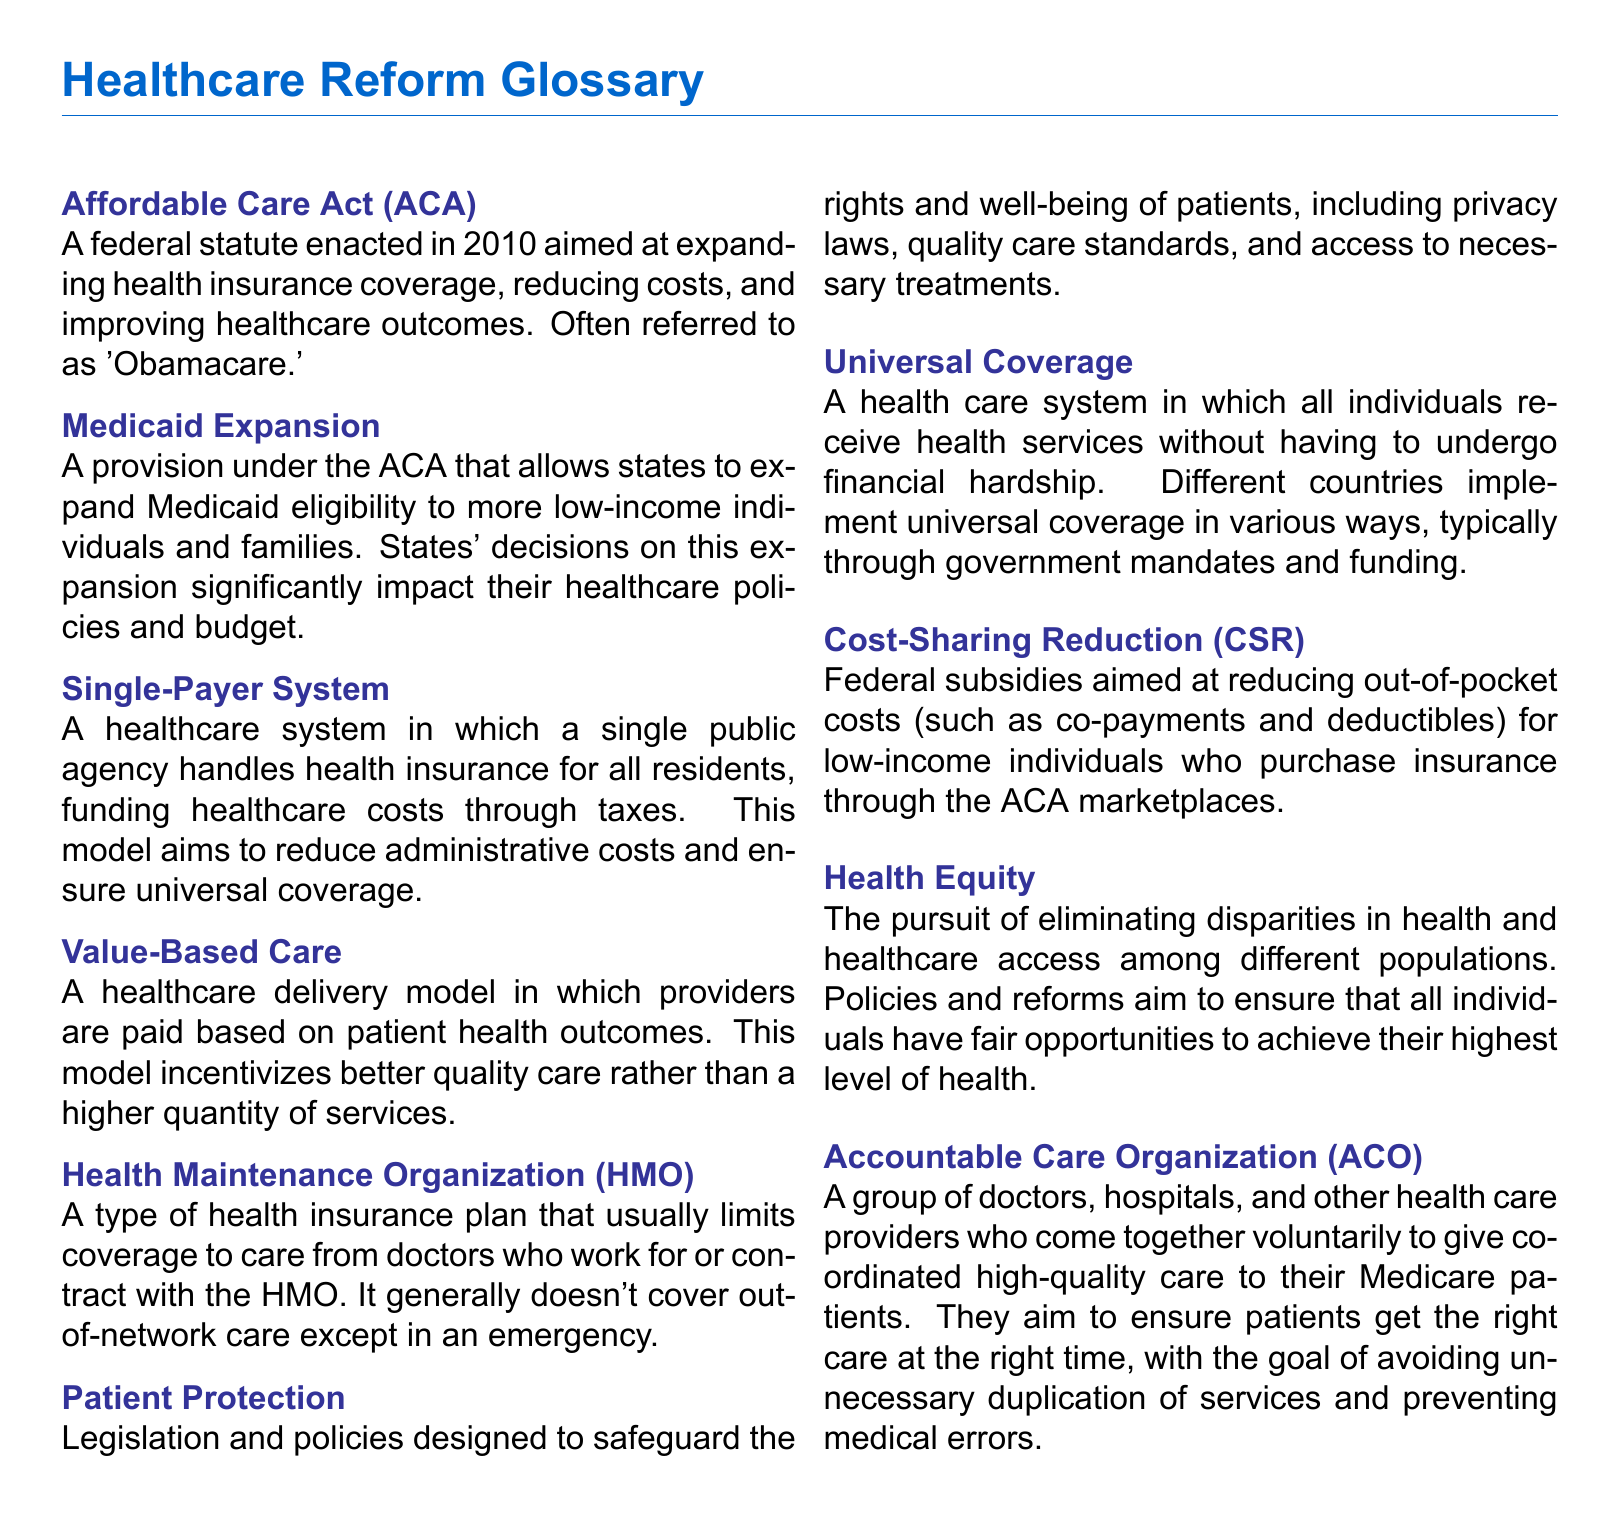What is the Affordable Care Act often referred to as? The document states that the Affordable Care Act is often referred to as 'Obamacare.'
Answer: 'Obamacare' What does Medicaid Expansion allow states to do? According to the document, Medicaid Expansion allows states to expand Medicaid eligibility to more low-income individuals and families.
Answer: Expand Medicaid eligibility What is the primary aim of a Single-Payer System? The document describes that a Single-Payer System aims to reduce administrative costs and ensure universal coverage.
Answer: Reduce administrative costs and ensure universal coverage Which care delivery model incentivizes better quality care? The document indicates that Value-Based Care incentivizes better quality care rather than higher quantity of services.
Answer: Value-Based Care What do Cost-Sharing Reductions (CSR) aim to reduce? As stated in the document, Cost-Sharing Reductions aim to reduce out-of-pocket costs for low-income individuals.
Answer: Out-of-pocket costs How many types of organizations are included in the definition of Accountable Care Organization (ACO)? The document mentions a group of doctors, hospitals, and other health care providers, implying that there are three types included.
Answer: Three types What is a key aspect of Patient Protection legislation? The document highlights that Patient Protection includes safeguarding the rights and well-being of patients.
Answer: Safeguarding rights and well-being What does Health Equity pursue? The document states that Health Equity pursues eliminating disparities in health and healthcare access among different populations.
Answer: Eliminating disparities How is Universal Coverage achieved according to the document? The document mentions that Universal Coverage is typically achieved through government mandates and funding.
Answer: Government mandates and funding 